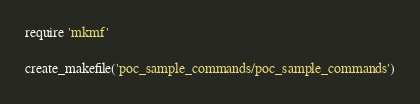Convert code to text. <code><loc_0><loc_0><loc_500><loc_500><_Ruby_>require 'mkmf'

create_makefile('poc_sample_commands/poc_sample_commands')
</code> 